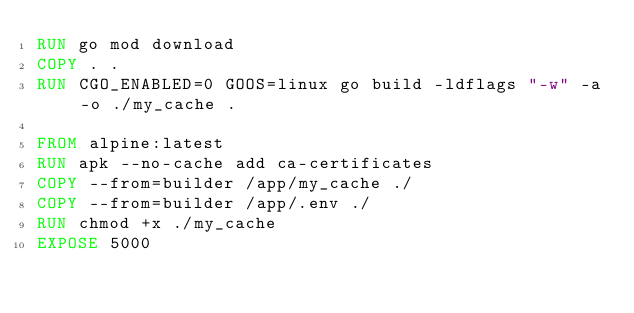Convert code to text. <code><loc_0><loc_0><loc_500><loc_500><_Dockerfile_>RUN go mod download
COPY . .
RUN CGO_ENABLED=0 GOOS=linux go build -ldflags "-w" -a -o ./my_cache .

FROM alpine:latest
RUN apk --no-cache add ca-certificates
COPY --from=builder /app/my_cache ./
COPY --from=builder /app/.env ./
RUN chmod +x ./my_cache
EXPOSE 5000
</code> 